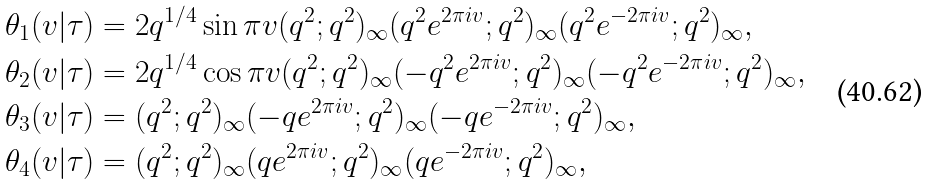<formula> <loc_0><loc_0><loc_500><loc_500>\theta _ { 1 } ( v | \tau ) & = 2 q ^ { 1 / 4 } \sin \pi v ( q ^ { 2 } ; q ^ { 2 } ) _ { \infty } ( q ^ { 2 } e ^ { 2 \pi i v } ; q ^ { 2 } ) _ { \infty } ( q ^ { 2 } e ^ { - 2 \pi i v } ; q ^ { 2 } ) _ { \infty } , \\ \theta _ { 2 } ( v | \tau ) & = 2 q ^ { 1 / 4 } \cos \pi v ( q ^ { 2 } ; q ^ { 2 } ) _ { \infty } ( - q ^ { 2 } e ^ { 2 \pi i v } ; q ^ { 2 } ) _ { \infty } ( - q ^ { 2 } e ^ { - 2 \pi i v } ; q ^ { 2 } ) _ { \infty } , \\ \theta _ { 3 } ( v | \tau ) & = ( q ^ { 2 } ; q ^ { 2 } ) _ { \infty } ( - q e ^ { 2 \pi i v } ; q ^ { 2 } ) _ { \infty } ( - q e ^ { - 2 \pi i v } ; q ^ { 2 } ) _ { \infty } , \\ \theta _ { 4 } ( v | \tau ) & = ( q ^ { 2 } ; q ^ { 2 } ) _ { \infty } ( q e ^ { 2 \pi i v } ; q ^ { 2 } ) _ { \infty } ( q e ^ { - 2 \pi i v } ; q ^ { 2 } ) _ { \infty } ,</formula> 